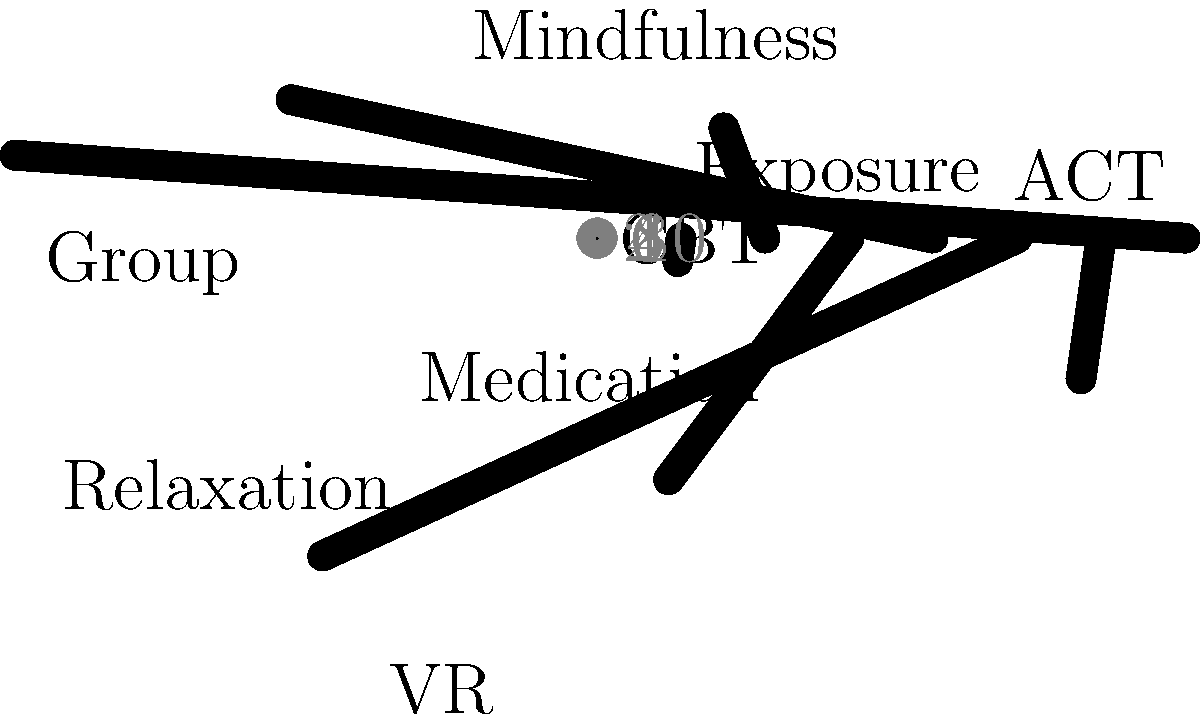Based on the polar bar chart showing the effectiveness of various treatment methods for social anxiety, which method appears to be the most effective, and what is its effectiveness score? To answer this question, we need to analyze the polar bar chart:

1. The chart displays 8 different treatment methods for social anxiety.
2. Each method is represented by a bar, with the length of the bar indicating its effectiveness score.
3. The effectiveness scores are measured on a scale from 0 to 10, with higher scores indicating greater effectiveness.
4. We need to identify the longest bar, which represents the most effective treatment method.

Examining the chart:
- CBT (Cognitive Behavioral Therapy): 8
- Exposure Therapy: 6
- Mindfulness: 7
- Medication: 5
- Group Therapy: 9
- Virtual Reality (VR) Therapy: 4
- Acceptance and Commitment Therapy (ACT): 6
- Relaxation Techniques: 3

The longest bar corresponds to Group Therapy, with a score of 9.
Answer: Group Therapy, 9 